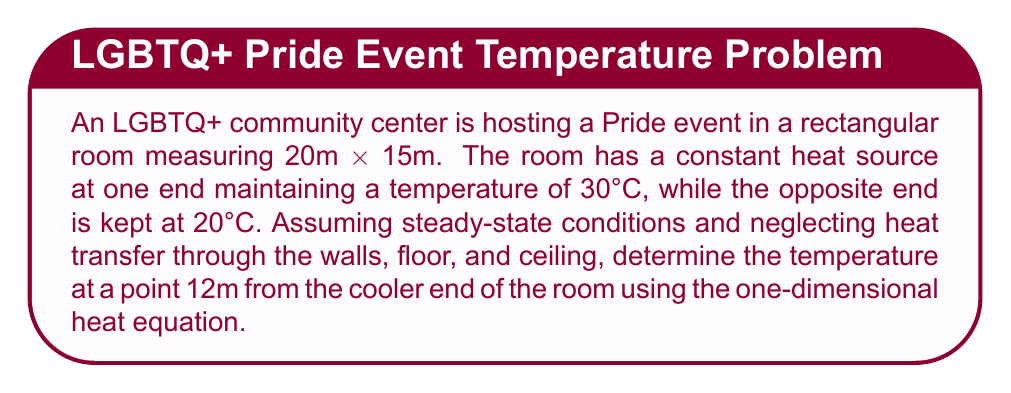What is the answer to this math problem? To solve this problem, we'll use the one-dimensional steady-state heat equation:

$$\frac{d^2T}{dx^2} = 0$$

The general solution to this equation is:

$$T(x) = Ax + B$$

where $A$ and $B$ are constants determined by the boundary conditions.

Given:
- Room length: $L = 20$ m
- Temperature at $x = 0$: $T(0) = 20°C$
- Temperature at $x = L = 20$: $T(20) = 30°C$

Step 1: Apply the boundary conditions:
$$T(0) = B = 20°C$$
$$T(20) = 20A + B = 30°C$$

Step 2: Solve for $A$:
$$20A + 20 = 30$$
$$20A = 10$$
$$A = 0.5$$

Step 3: The temperature distribution is given by:
$$T(x) = 0.5x + 20$$

Step 4: Calculate the temperature at $x = 12$ m:
$$T(12) = 0.5(12) + 20 = 26°C$$

Therefore, the temperature at a point 12m from the cooler end of the room is 26°C.
Answer: 26°C 